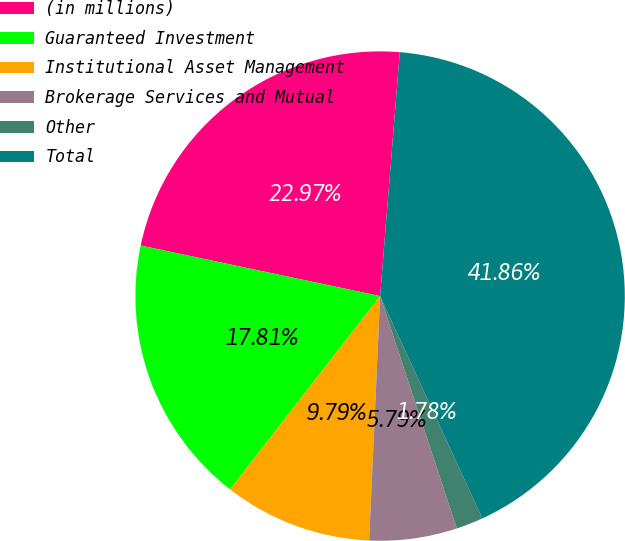<chart> <loc_0><loc_0><loc_500><loc_500><pie_chart><fcel>(in millions)<fcel>Guaranteed Investment<fcel>Institutional Asset Management<fcel>Brokerage Services and Mutual<fcel>Other<fcel>Total<nl><fcel>22.97%<fcel>17.81%<fcel>9.79%<fcel>5.79%<fcel>1.78%<fcel>41.86%<nl></chart> 